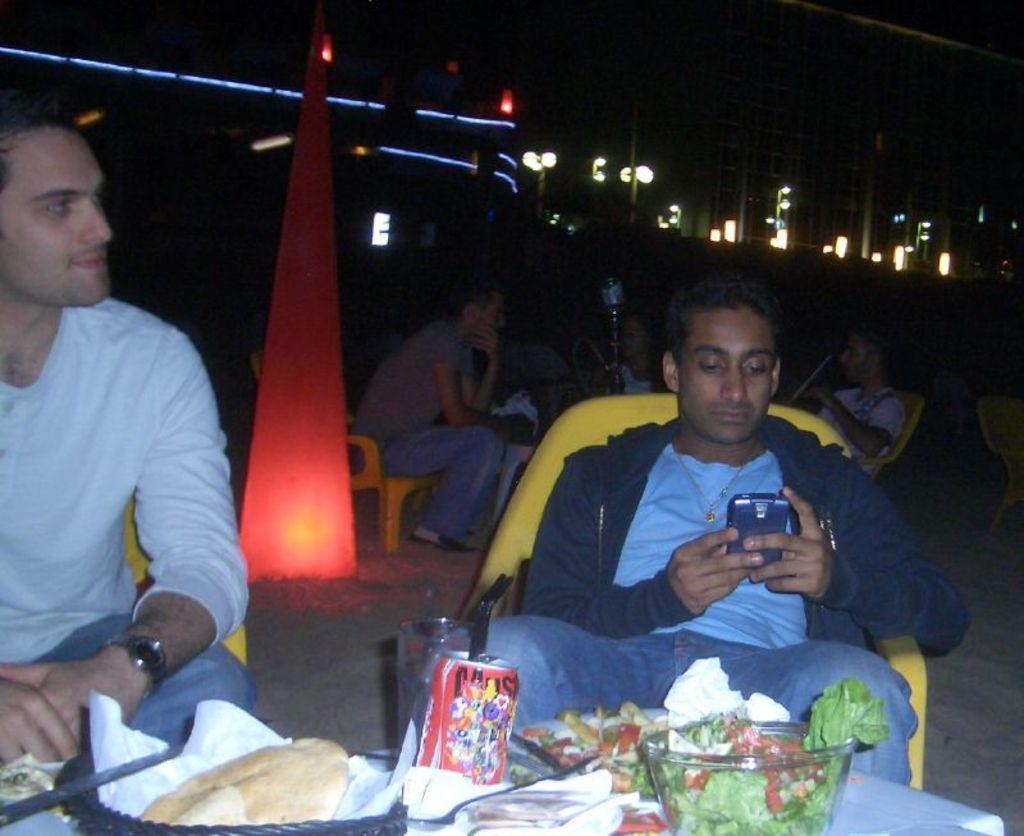Please provide a concise description of this image. In this image, we can see people are sitting on the chairs. We can see a person holding a mobile. At the bottom of the image, we can see food items and few things are on the white surface. In the background, we can see dark view, lights and poles. 